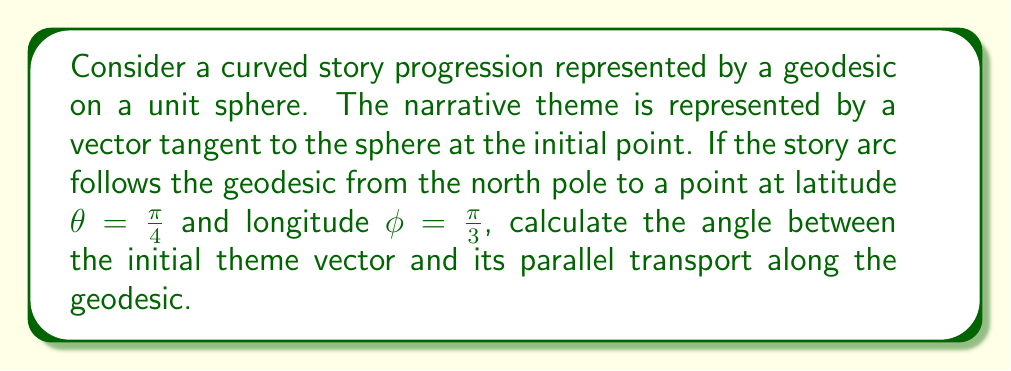Solve this math problem. To solve this problem, we'll use concepts from differential geometry applied to storytelling:

1) First, we need to understand that parallel transport on a sphere preserves the angle between the transported vector and the geodesic.

2) The initial point (north pole) has coordinates $(0, 0, 1)$ in Cartesian system.

3) The final point coordinates are:
   $$x = \cos(\frac{\pi}{4}) \cos(\frac{\pi}{3})$$
   $$y = \cos(\frac{\pi}{4}) \sin(\frac{\pi}{3})$$
   $$z = \sin(\frac{\pi}{4})$$

4) The geodesic between these points is a great circle. The angle between the initial and final position vectors is the same as the angle of parallel transport.

5) We can calculate this angle using the dot product:
   $$\cos(\theta) = \frac{(0, 0, 1) \cdot (x, y, z)}{|(0, 0, 1)| |(x, y, z)|}$$

6) Simplifying:
   $$\cos(\theta) = z = \sin(\frac{\pi}{4}) = \frac{\sqrt{2}}{2}$$

7) Therefore, the angle of parallel transport is:
   $$\theta = \arccos(\frac{\sqrt{2}}{2}) = \frac{\pi}{4}$$

This angle represents how much the narrative theme has "rotated" as it's been parallel transported along the curved story progression.
Answer: $\frac{\pi}{4}$ radians 